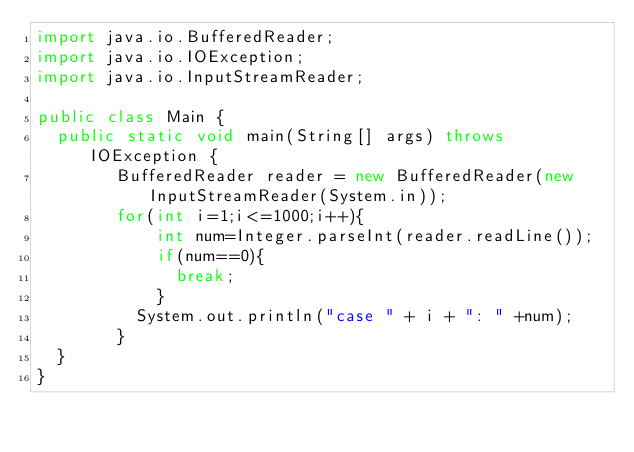<code> <loc_0><loc_0><loc_500><loc_500><_Java_>import java.io.BufferedReader;
import java.io.IOException;
import java.io.InputStreamReader;

public class Main {
	public static void main(String[] args) throws IOException {
        BufferedReader reader = new BufferedReader(new InputStreamReader(System.in));
        for(int i=1;i<=1000;i++){
            int num=Integer.parseInt(reader.readLine());
            if(num==0){
            	break;
            }
        	System.out.println("case " + i + ": " +num);
        }
	}
}</code> 